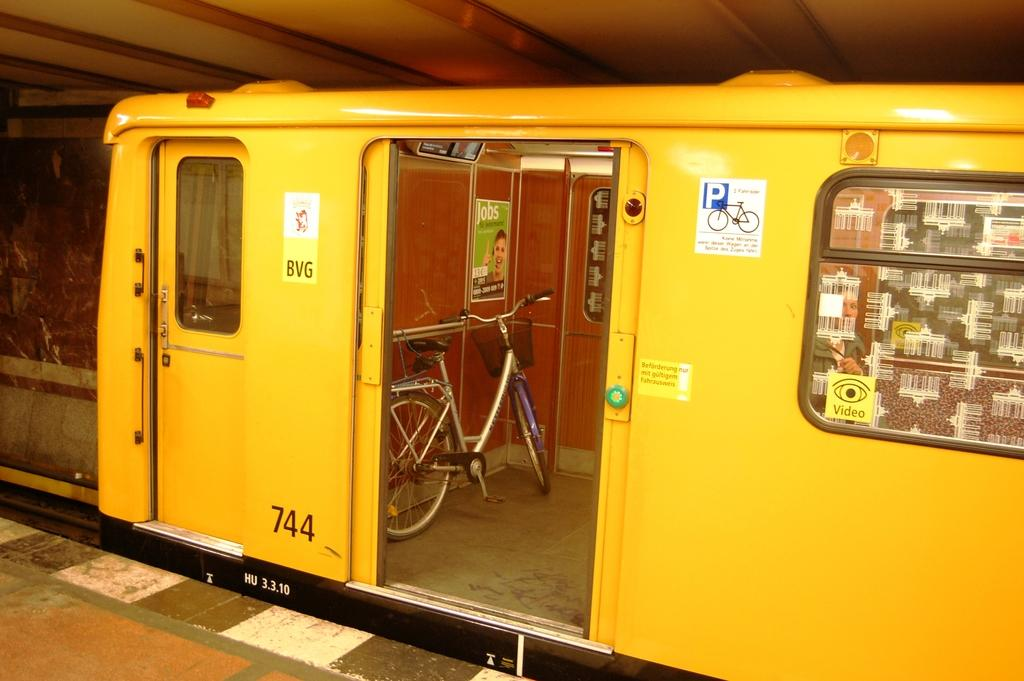What is the main subject of the image? The main subject of the image is a train. Can you describe the train in the image? The train is in the center of the image, and a bicycle is placed inside it. What is visible at the bottom of the image? There is a platform visible at the bottom of the image. How many boys are sitting on the furniture inside the train? There is no mention of boys or furniture inside the train in the image. 